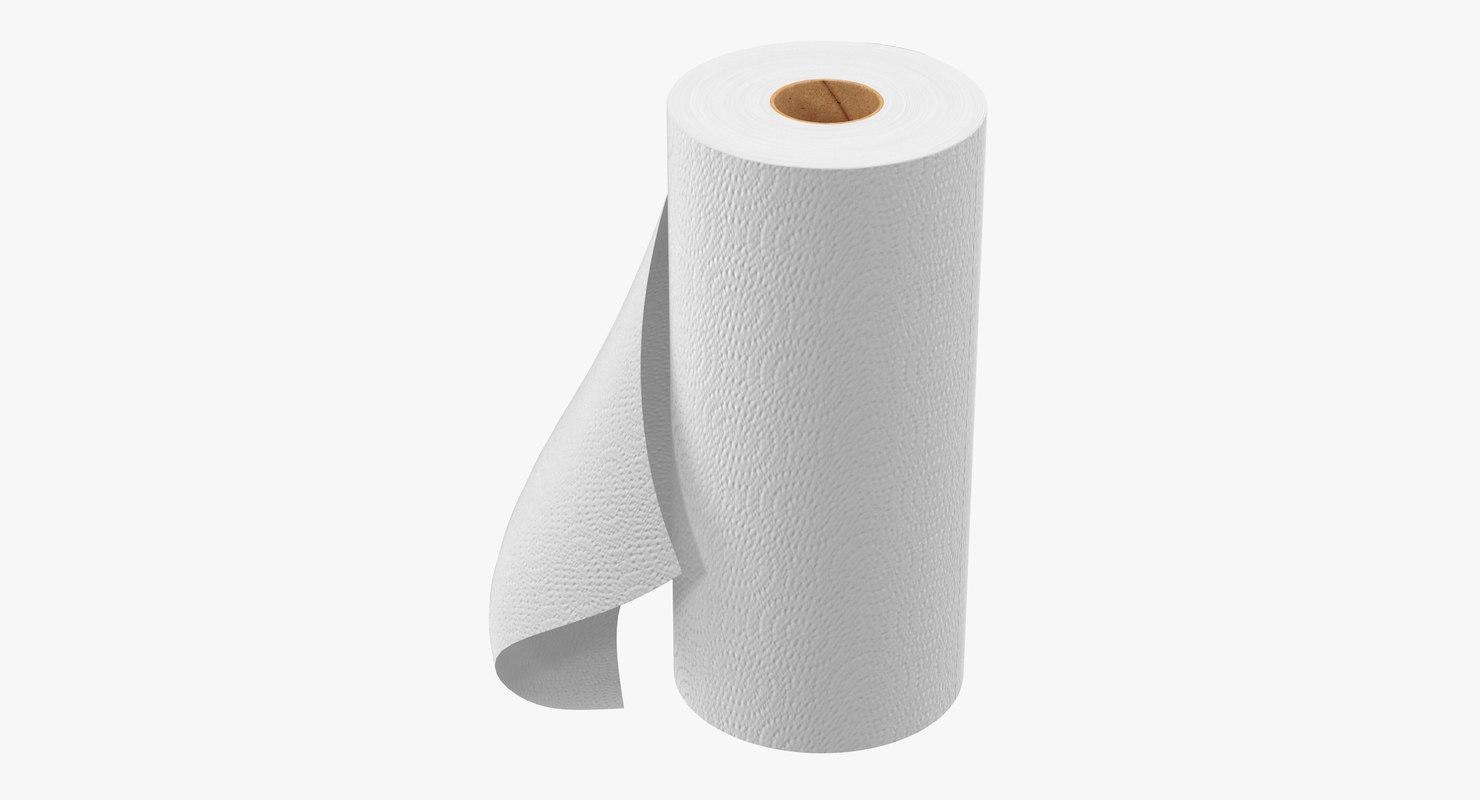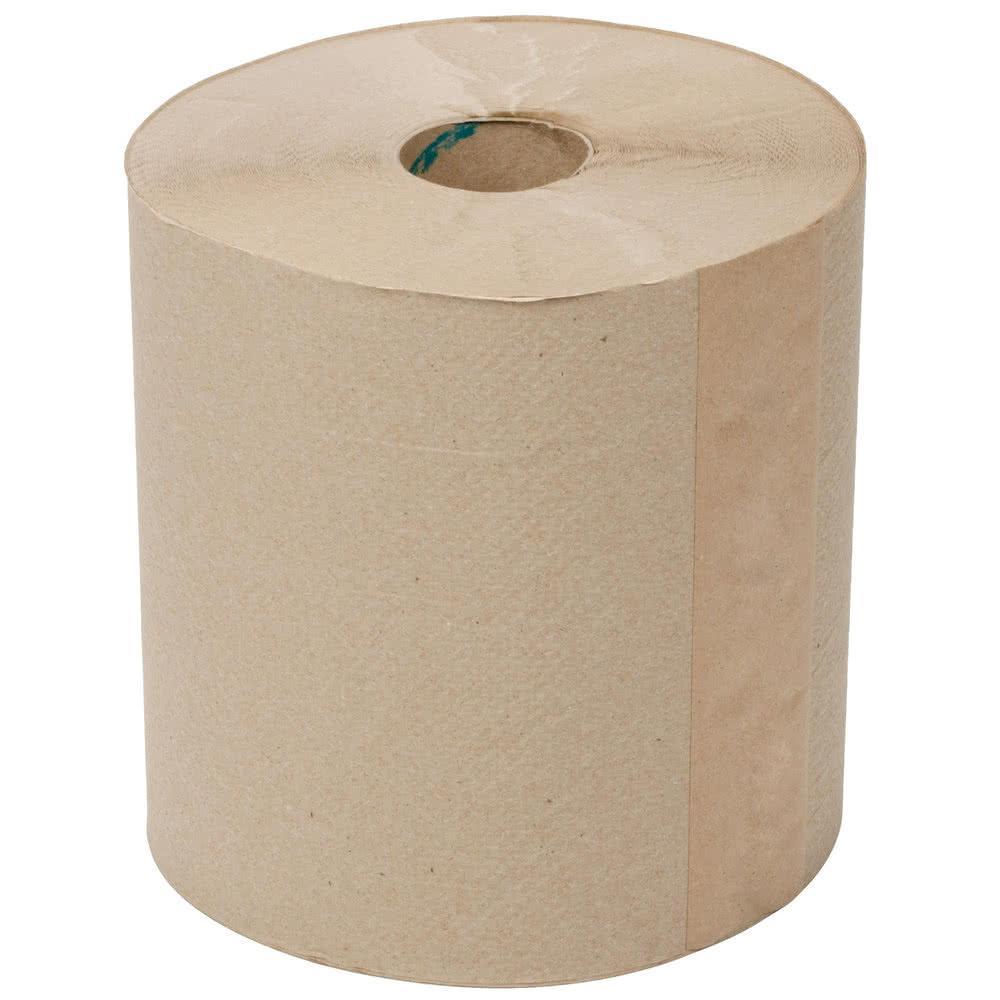The first image is the image on the left, the second image is the image on the right. Analyze the images presented: Is the assertion "One of the images shows folded paper towels." valid? Answer yes or no. No. The first image is the image on the left, the second image is the image on the right. Given the left and right images, does the statement "one of the images contains two stacks of paper towels." hold true? Answer yes or no. No. 